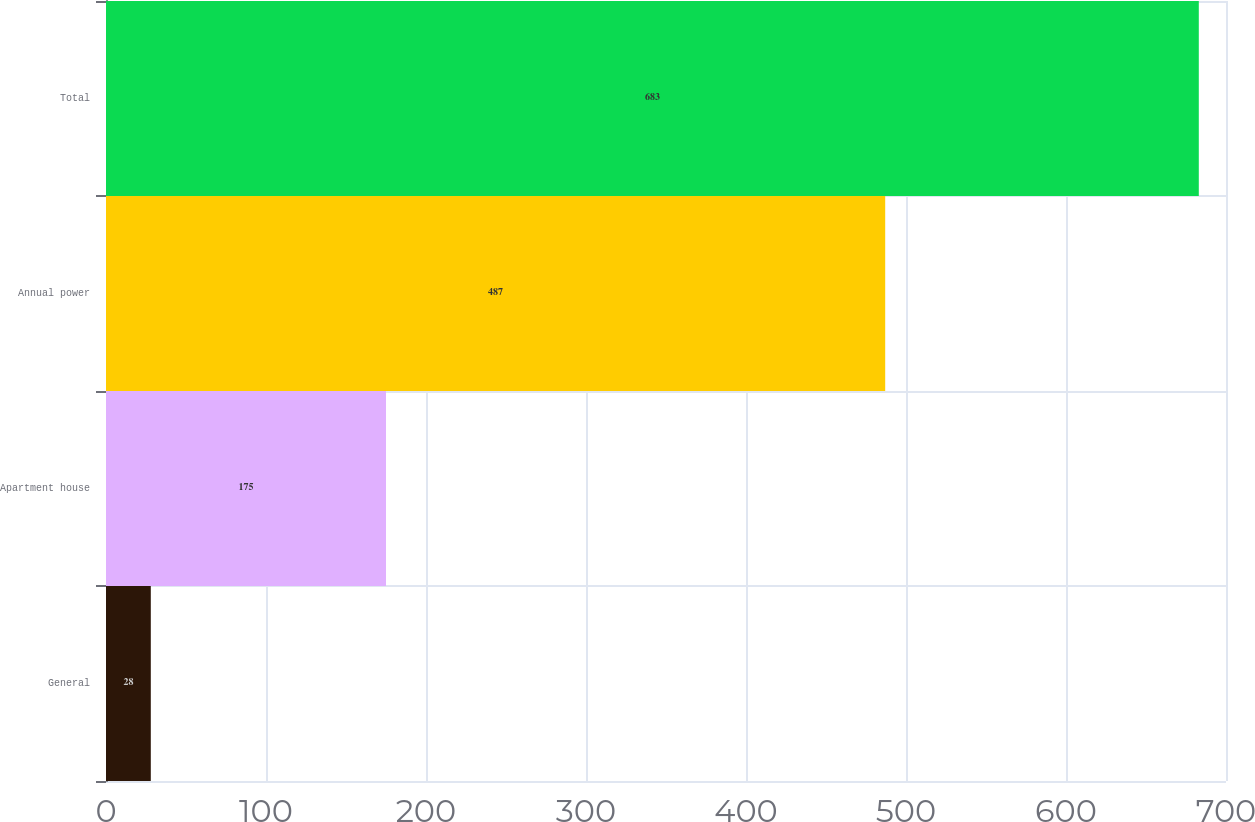Convert chart. <chart><loc_0><loc_0><loc_500><loc_500><bar_chart><fcel>General<fcel>Apartment house<fcel>Annual power<fcel>Total<nl><fcel>28<fcel>175<fcel>487<fcel>683<nl></chart> 